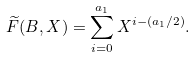Convert formula to latex. <formula><loc_0><loc_0><loc_500><loc_500>\widetilde { F } ( B , X ) = \sum _ { i = 0 } ^ { a _ { 1 } } X ^ { i - ( a _ { 1 } / 2 ) } .</formula> 